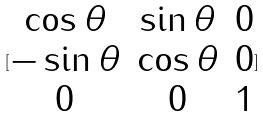<formula> <loc_0><loc_0><loc_500><loc_500>[ \begin{matrix} \cos \theta & \sin \theta & 0 \\ - \sin \theta & \cos \theta & 0 \\ 0 & 0 & 1 \end{matrix} ]</formula> 